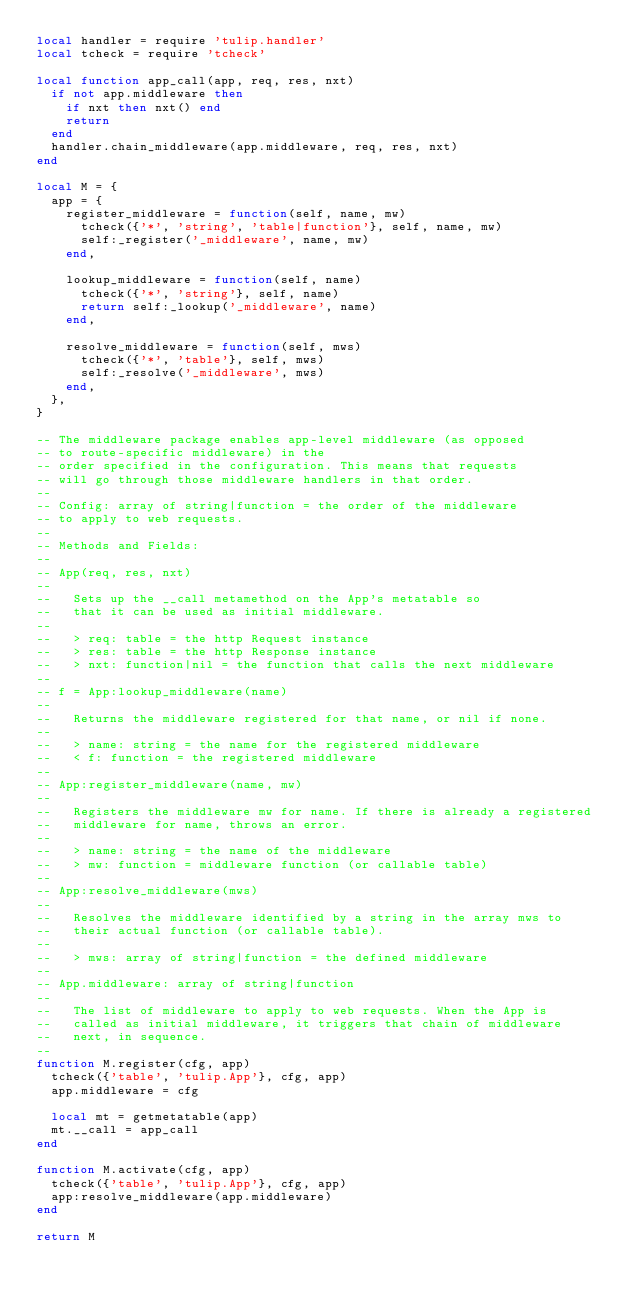Convert code to text. <code><loc_0><loc_0><loc_500><loc_500><_Lua_>local handler = require 'tulip.handler'
local tcheck = require 'tcheck'

local function app_call(app, req, res, nxt)
  if not app.middleware then
    if nxt then nxt() end
    return
  end
  handler.chain_middleware(app.middleware, req, res, nxt)
end

local M = {
  app = {
    register_middleware = function(self, name, mw)
      tcheck({'*', 'string', 'table|function'}, self, name, mw)
      self:_register('_middleware', name, mw)
    end,

    lookup_middleware = function(self, name)
      tcheck({'*', 'string'}, self, name)
      return self:_lookup('_middleware', name)
    end,

    resolve_middleware = function(self, mws)
      tcheck({'*', 'table'}, self, mws)
      self:_resolve('_middleware', mws)
    end,
  },
}

-- The middleware package enables app-level middleware (as opposed
-- to route-specific middleware) in the
-- order specified in the configuration. This means that requests
-- will go through those middleware handlers in that order.
--
-- Config: array of string|function = the order of the middleware
-- to apply to web requests.
--
-- Methods and Fields:
--
-- App(req, res, nxt)
--
--   Sets up the __call metamethod on the App's metatable so
--   that it can be used as initial middleware.
--
--   > req: table = the http Request instance
--   > res: table = the http Response instance
--   > nxt: function|nil = the function that calls the next middleware
--
-- f = App:lookup_middleware(name)
--
--   Returns the middleware registered for that name, or nil if none.
--
--   > name: string = the name for the registered middleware
--   < f: function = the registered middleware
--
-- App:register_middleware(name, mw)
--
--   Registers the middleware mw for name. If there is already a registered
--   middleware for name, throws an error.
--
--   > name: string = the name of the middleware
--   > mw: function = middleware function (or callable table)
--
-- App:resolve_middleware(mws)
--
--   Resolves the middleware identified by a string in the array mws to
--   their actual function (or callable table).
--
--   > mws: array of string|function = the defined middleware
--
-- App.middleware: array of string|function
--
--   The list of middleware to apply to web requests. When the App is
--   called as initial middleware, it triggers that chain of middleware
--   next, in sequence.
--
function M.register(cfg, app)
  tcheck({'table', 'tulip.App'}, cfg, app)
  app.middleware = cfg

  local mt = getmetatable(app)
  mt.__call = app_call
end

function M.activate(cfg, app)
  tcheck({'table', 'tulip.App'}, cfg, app)
  app:resolve_middleware(app.middleware)
end

return M
</code> 